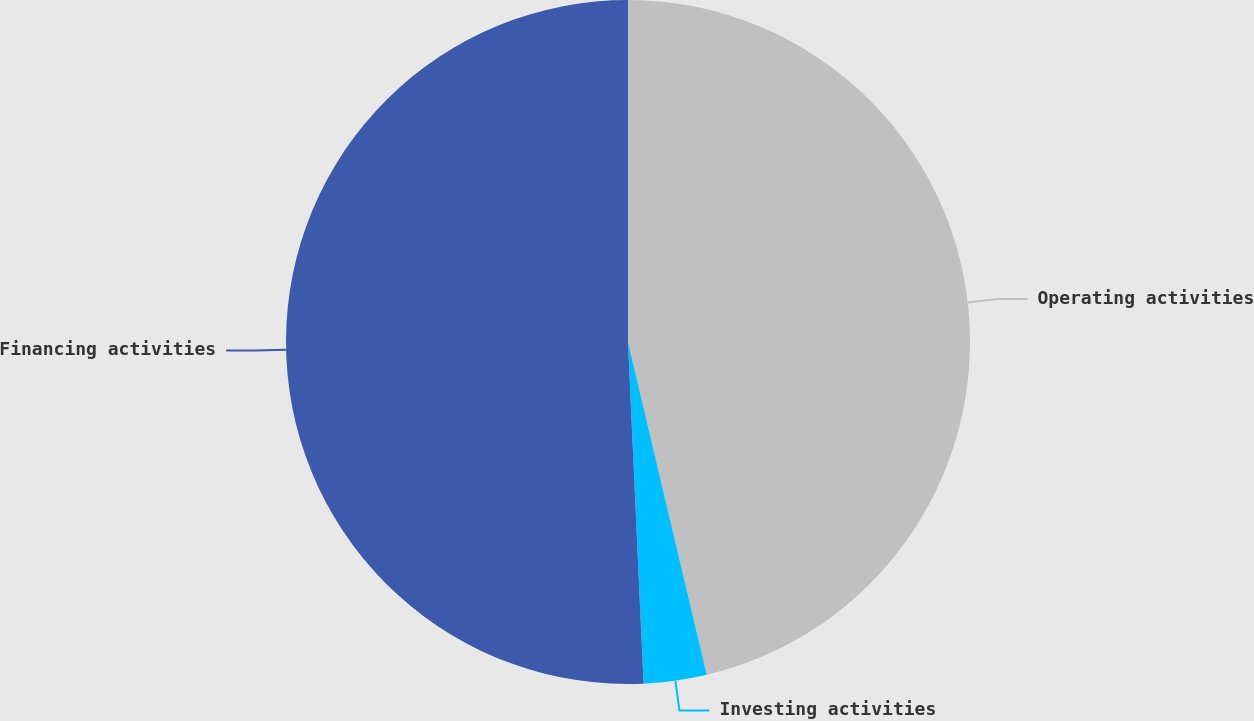<chart> <loc_0><loc_0><loc_500><loc_500><pie_chart><fcel>Operating activities<fcel>Investing activities<fcel>Financing activities<nl><fcel>46.31%<fcel>2.97%<fcel>50.73%<nl></chart> 